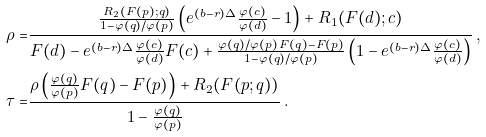Convert formula to latex. <formula><loc_0><loc_0><loc_500><loc_500>\rho = & \frac { \frac { R _ { 2 } ( F ( p ) ; q ) } { 1 - \varphi ( q ) / \varphi ( p ) } \left ( e ^ { ( b - r ) \Delta } \frac { \varphi ( c ) } { \varphi ( d ) } - 1 \right ) + R _ { 1 } ( F ( d ) ; c ) } { F ( d ) - e ^ { ( b - r ) \Delta } \frac { \varphi ( c ) } { \varphi ( d ) } F ( c ) + \frac { \varphi ( q ) / \varphi ( p ) \, F ( q ) - F ( p ) } { 1 - \varphi ( q ) / \varphi ( p ) } \left ( 1 - e ^ { ( b - r ) \Delta } \frac { \varphi ( c ) } { \varphi ( d ) } \right ) } \, , \\ \tau = & \frac { \rho \left ( \frac { \varphi ( q ) } { \varphi ( p ) } F ( q ) - F ( p ) \right ) + R _ { 2 } ( F ( p ; q ) ) } { 1 - \frac { \varphi ( q ) } { \varphi ( p ) } } \, .</formula> 